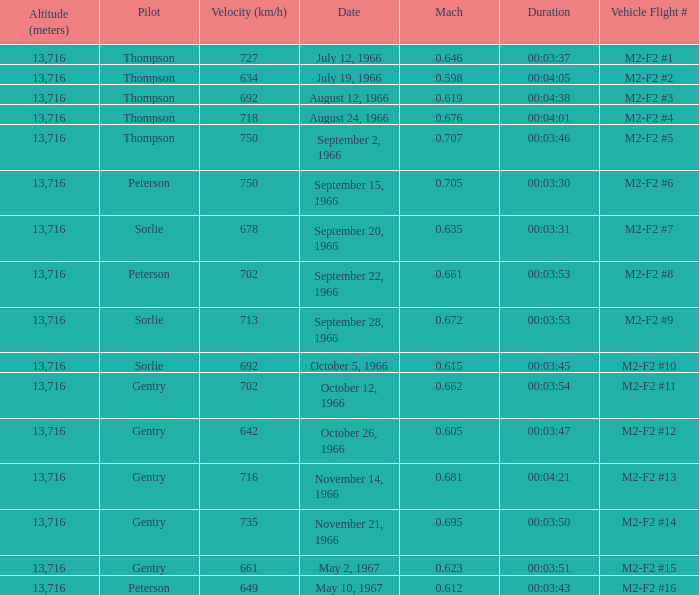What Date has a Mach of 0.662? October 12, 1966. 